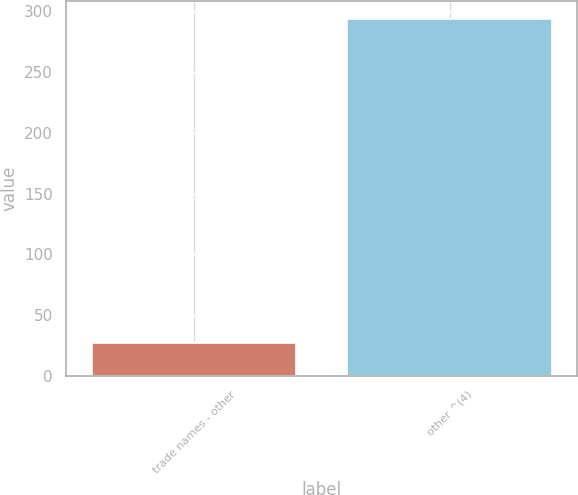Convert chart. <chart><loc_0><loc_0><loc_500><loc_500><bar_chart><fcel>trade names - other<fcel>other ^(4)<nl><fcel>27.4<fcel>294<nl></chart> 